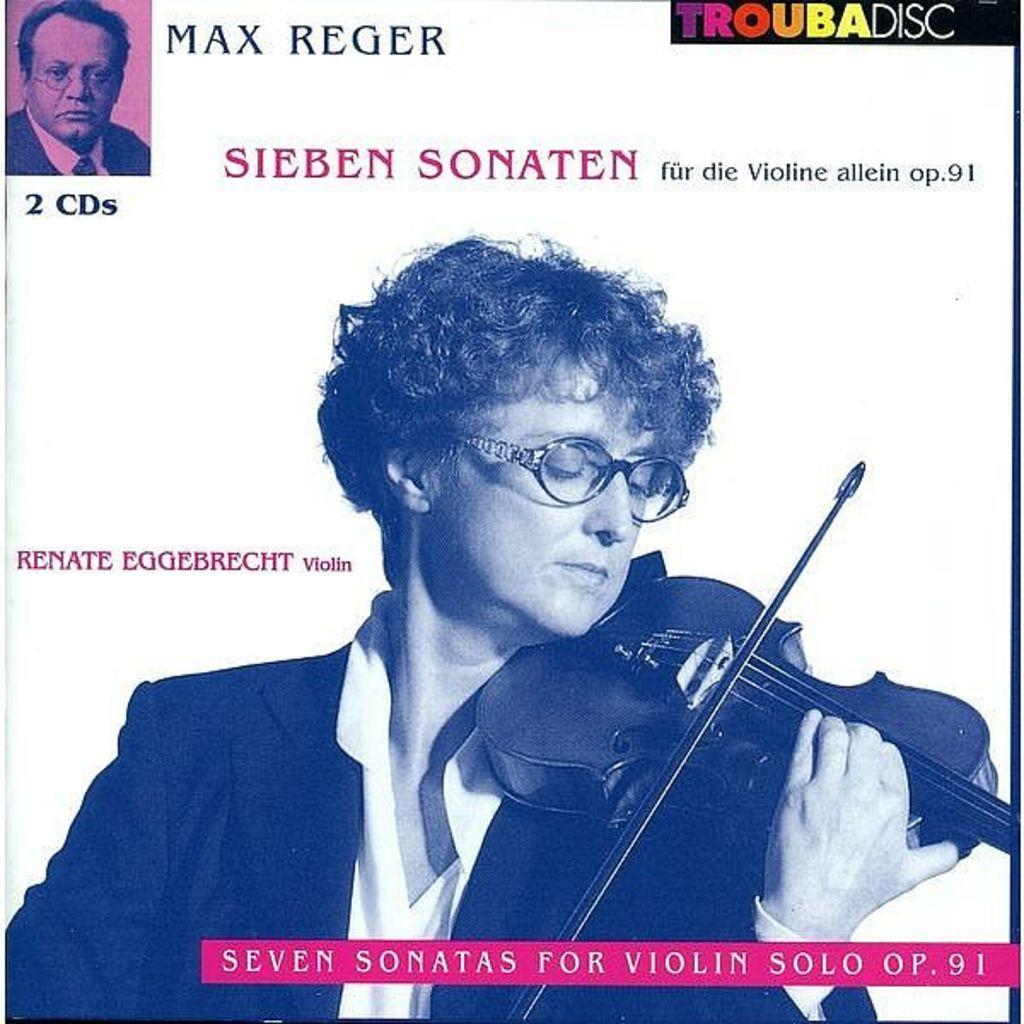Who is depicted in the poster? There is a woman in the poster. What is the woman wearing in the poster? The woman is wearing spectacles and a suit in the poster. What is the woman doing in the poster? The woman is playing a violin in the poster. What other image can be seen on the poster? There is a picture of a person at the top of the poster. Is the woman driving a car in the poster? No, the woman is not driving a car in the poster; she is playing a violin. Is there a party happening in the poster? There is no indication of a party in the poster; it features a woman playing a violin and a picture of a person at the top. 